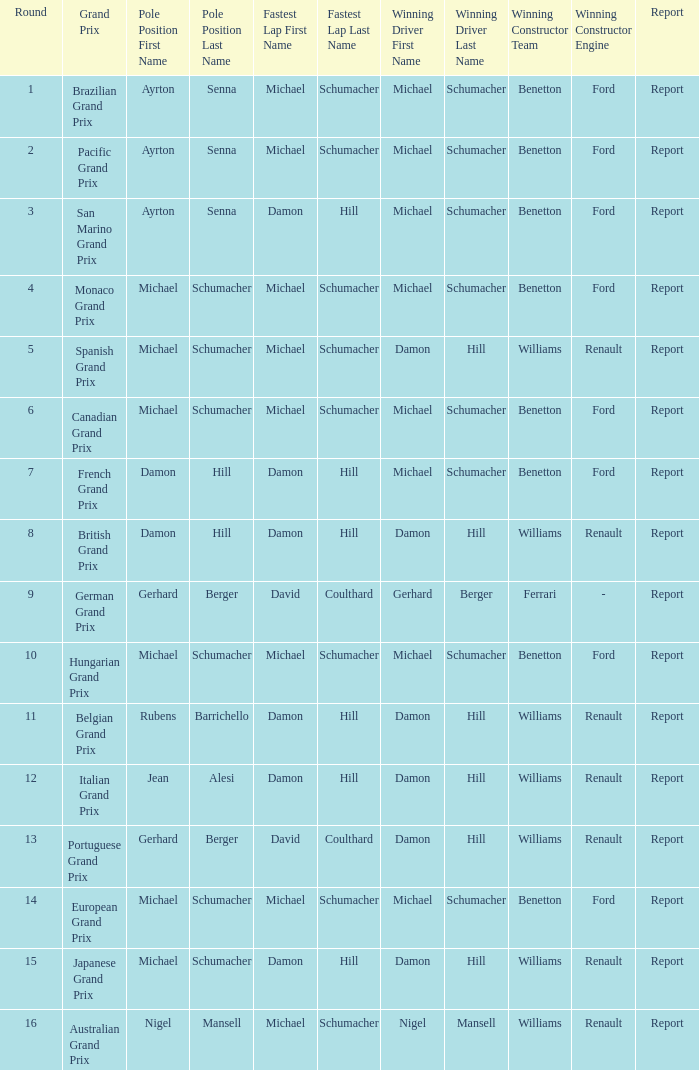What is the initial round where michael schumacher secures pole position and wins the race? 4.0. 